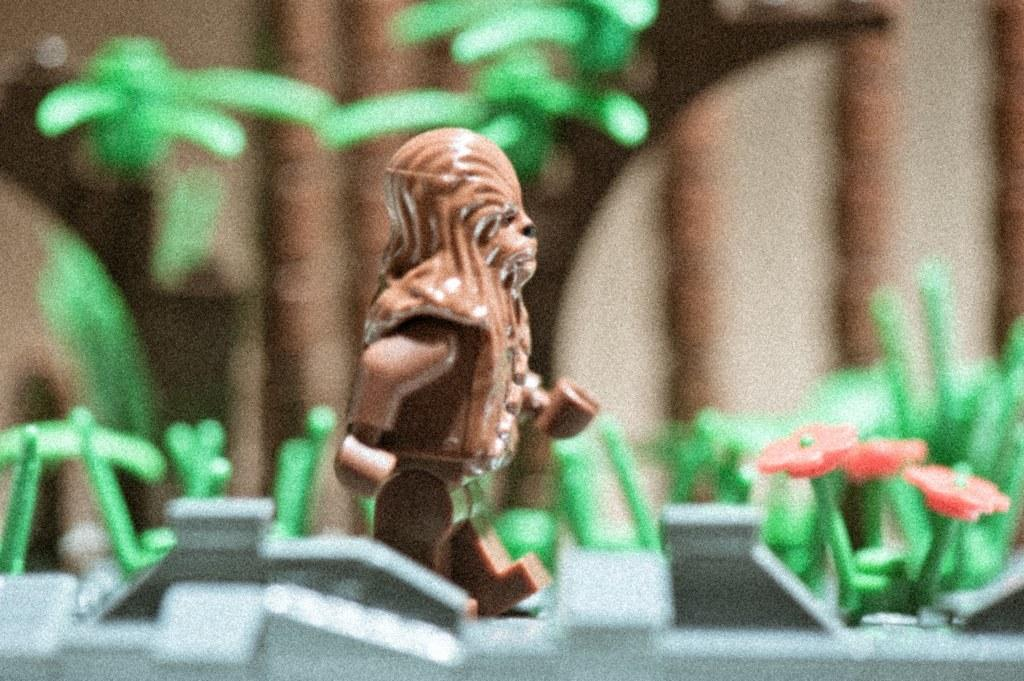What is the main subject of the image? There is a miniature in the image. Can you describe the brown object in the image? There is a brown color object in the image. What type of vegetation is present in the image? There is grass in the image, which is green in color. What color are the flowers in the image? The flowers in the image are red in color. How would you describe the background of the image? The background of the image is blurred. What type of crate is being used for arithmetic in the image? There is no crate or arithmetic present in the image. How does the image stop the viewer from interacting with the scene? The image does not stop the viewer from interacting with the scene; it is a static image that can be viewed and analyzed. 